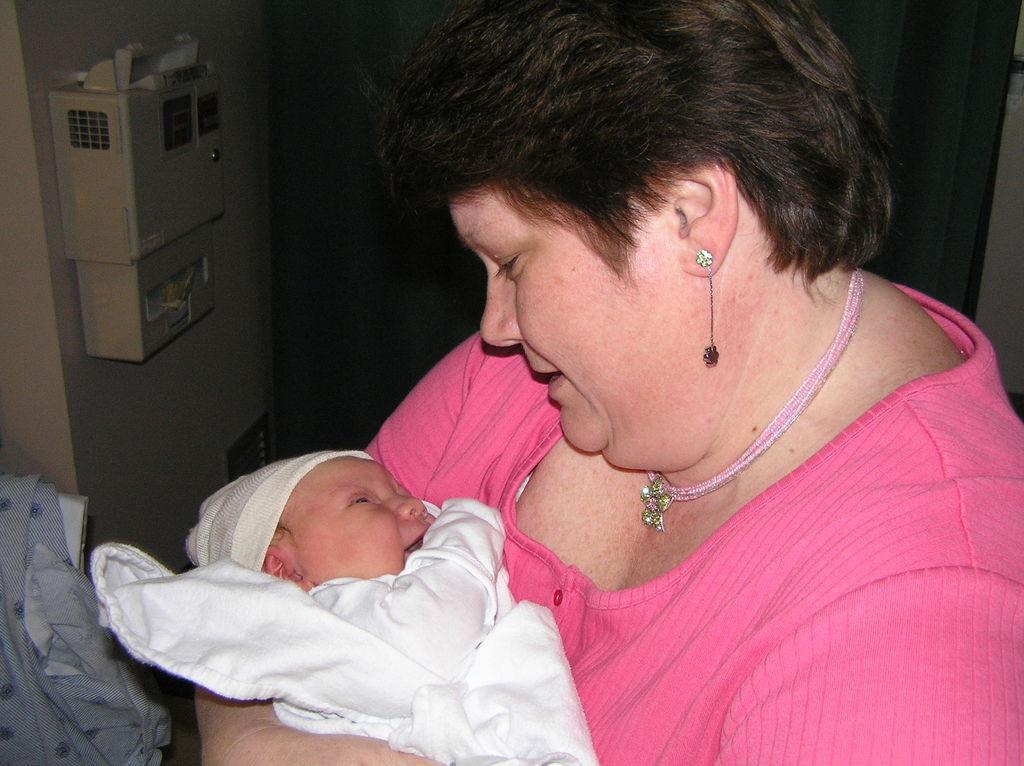Describe this image in one or two sentences. In this image we can see a woman carrying a baby. Behind the woman we can see a wall. On the left side, we can see a box on the wall. In the bottom left we can see a cloth. 